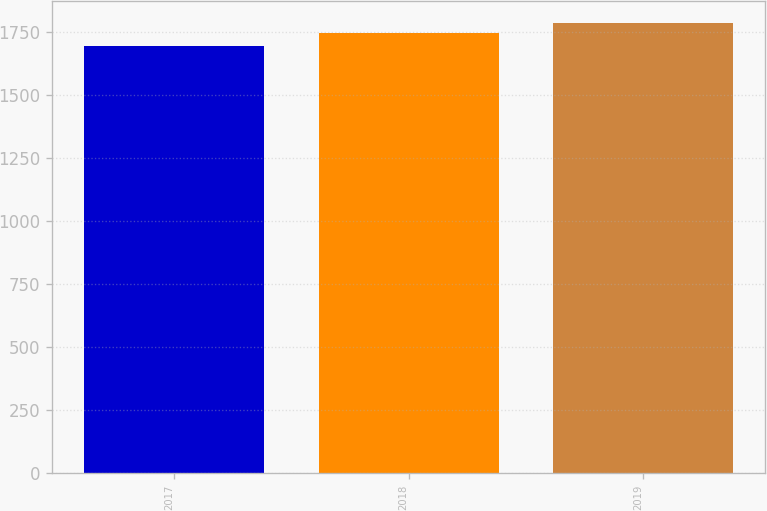Convert chart to OTSL. <chart><loc_0><loc_0><loc_500><loc_500><bar_chart><fcel>2017<fcel>2018<fcel>2019<nl><fcel>1695<fcel>1746<fcel>1785<nl></chart> 